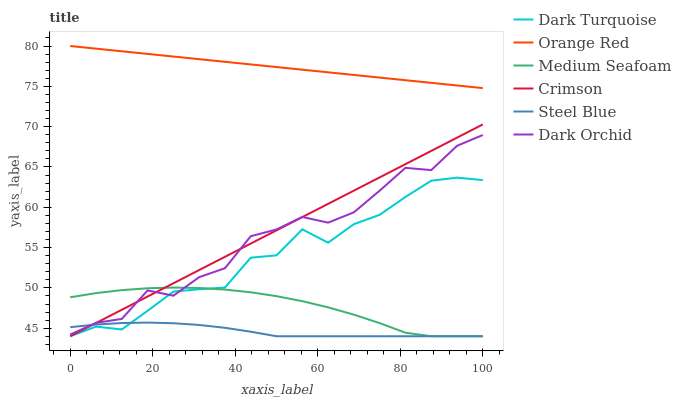Does Steel Blue have the minimum area under the curve?
Answer yes or no. Yes. Does Orange Red have the maximum area under the curve?
Answer yes or no. Yes. Does Dark Orchid have the minimum area under the curve?
Answer yes or no. No. Does Dark Orchid have the maximum area under the curve?
Answer yes or no. No. Is Orange Red the smoothest?
Answer yes or no. Yes. Is Dark Orchid the roughest?
Answer yes or no. Yes. Is Steel Blue the smoothest?
Answer yes or no. No. Is Steel Blue the roughest?
Answer yes or no. No. Does Dark Turquoise have the lowest value?
Answer yes or no. Yes. Does Dark Orchid have the lowest value?
Answer yes or no. No. Does Orange Red have the highest value?
Answer yes or no. Yes. Does Dark Orchid have the highest value?
Answer yes or no. No. Is Medium Seafoam less than Orange Red?
Answer yes or no. Yes. Is Orange Red greater than Medium Seafoam?
Answer yes or no. Yes. Does Crimson intersect Dark Turquoise?
Answer yes or no. Yes. Is Crimson less than Dark Turquoise?
Answer yes or no. No. Is Crimson greater than Dark Turquoise?
Answer yes or no. No. Does Medium Seafoam intersect Orange Red?
Answer yes or no. No. 